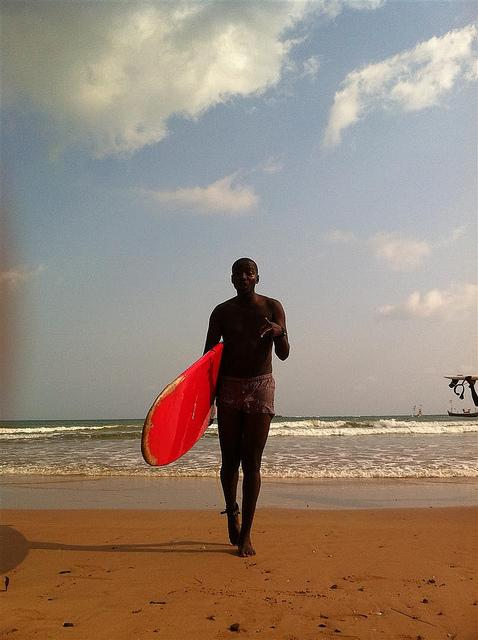What country is this most likely? africa 